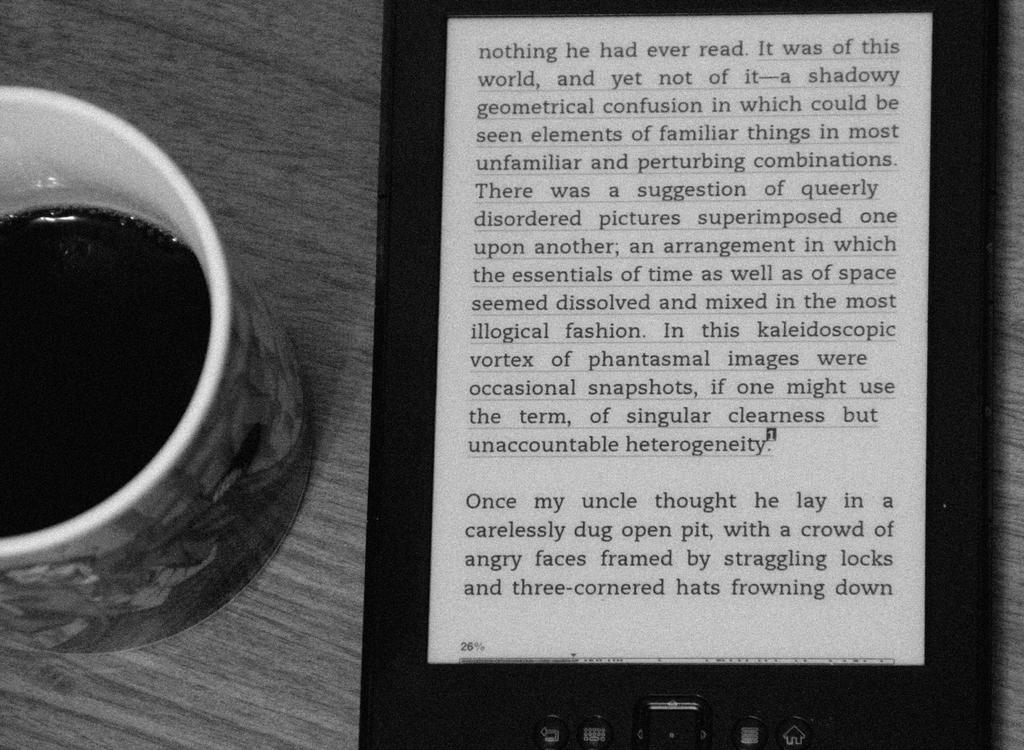<image>
Write a terse but informative summary of the picture. The current page on the e-reader begins with the word "nothing". 